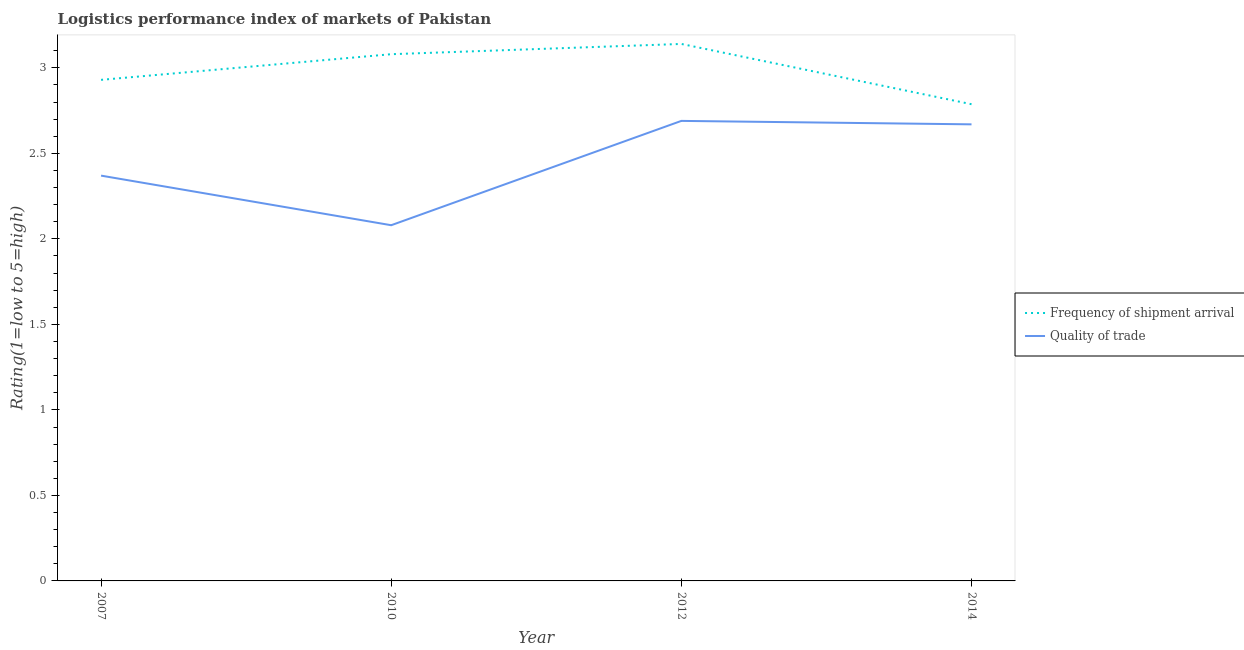Does the line corresponding to lpi of frequency of shipment arrival intersect with the line corresponding to lpi quality of trade?
Make the answer very short. No. What is the lpi of frequency of shipment arrival in 2012?
Give a very brief answer. 3.14. Across all years, what is the maximum lpi quality of trade?
Make the answer very short. 2.69. Across all years, what is the minimum lpi of frequency of shipment arrival?
Provide a succinct answer. 2.79. In which year was the lpi of frequency of shipment arrival maximum?
Ensure brevity in your answer.  2012. What is the total lpi quality of trade in the graph?
Keep it short and to the point. 9.81. What is the difference between the lpi quality of trade in 2007 and that in 2010?
Your answer should be very brief. 0.29. What is the difference between the lpi quality of trade in 2012 and the lpi of frequency of shipment arrival in 2007?
Give a very brief answer. -0.24. What is the average lpi quality of trade per year?
Give a very brief answer. 2.45. In the year 2007, what is the difference between the lpi quality of trade and lpi of frequency of shipment arrival?
Keep it short and to the point. -0.56. What is the ratio of the lpi of frequency of shipment arrival in 2010 to that in 2012?
Provide a short and direct response. 0.98. What is the difference between the highest and the second highest lpi quality of trade?
Your response must be concise. 0.02. What is the difference between the highest and the lowest lpi of frequency of shipment arrival?
Your answer should be very brief. 0.35. Is the sum of the lpi quality of trade in 2012 and 2014 greater than the maximum lpi of frequency of shipment arrival across all years?
Offer a very short reply. Yes. Does the lpi quality of trade monotonically increase over the years?
Keep it short and to the point. No. Is the lpi quality of trade strictly greater than the lpi of frequency of shipment arrival over the years?
Your answer should be compact. No. How many years are there in the graph?
Ensure brevity in your answer.  4. What is the difference between two consecutive major ticks on the Y-axis?
Ensure brevity in your answer.  0.5. Are the values on the major ticks of Y-axis written in scientific E-notation?
Offer a terse response. No. What is the title of the graph?
Provide a succinct answer. Logistics performance index of markets of Pakistan. Does "International Visitors" appear as one of the legend labels in the graph?
Keep it short and to the point. No. What is the label or title of the X-axis?
Your response must be concise. Year. What is the label or title of the Y-axis?
Keep it short and to the point. Rating(1=low to 5=high). What is the Rating(1=low to 5=high) of Frequency of shipment arrival in 2007?
Your response must be concise. 2.93. What is the Rating(1=low to 5=high) of Quality of trade in 2007?
Give a very brief answer. 2.37. What is the Rating(1=low to 5=high) in Frequency of shipment arrival in 2010?
Provide a succinct answer. 3.08. What is the Rating(1=low to 5=high) of Quality of trade in 2010?
Your answer should be very brief. 2.08. What is the Rating(1=low to 5=high) of Frequency of shipment arrival in 2012?
Ensure brevity in your answer.  3.14. What is the Rating(1=low to 5=high) of Quality of trade in 2012?
Give a very brief answer. 2.69. What is the Rating(1=low to 5=high) in Frequency of shipment arrival in 2014?
Provide a succinct answer. 2.79. What is the Rating(1=low to 5=high) of Quality of trade in 2014?
Keep it short and to the point. 2.67. Across all years, what is the maximum Rating(1=low to 5=high) of Frequency of shipment arrival?
Provide a short and direct response. 3.14. Across all years, what is the maximum Rating(1=low to 5=high) in Quality of trade?
Make the answer very short. 2.69. Across all years, what is the minimum Rating(1=low to 5=high) in Frequency of shipment arrival?
Offer a terse response. 2.79. Across all years, what is the minimum Rating(1=low to 5=high) of Quality of trade?
Make the answer very short. 2.08. What is the total Rating(1=low to 5=high) of Frequency of shipment arrival in the graph?
Offer a very short reply. 11.94. What is the total Rating(1=low to 5=high) in Quality of trade in the graph?
Your response must be concise. 9.81. What is the difference between the Rating(1=low to 5=high) in Frequency of shipment arrival in 2007 and that in 2010?
Give a very brief answer. -0.15. What is the difference between the Rating(1=low to 5=high) in Quality of trade in 2007 and that in 2010?
Your response must be concise. 0.29. What is the difference between the Rating(1=low to 5=high) of Frequency of shipment arrival in 2007 and that in 2012?
Give a very brief answer. -0.21. What is the difference between the Rating(1=low to 5=high) of Quality of trade in 2007 and that in 2012?
Your response must be concise. -0.32. What is the difference between the Rating(1=low to 5=high) of Frequency of shipment arrival in 2007 and that in 2014?
Ensure brevity in your answer.  0.14. What is the difference between the Rating(1=low to 5=high) of Quality of trade in 2007 and that in 2014?
Provide a succinct answer. -0.3. What is the difference between the Rating(1=low to 5=high) of Frequency of shipment arrival in 2010 and that in 2012?
Give a very brief answer. -0.06. What is the difference between the Rating(1=low to 5=high) in Quality of trade in 2010 and that in 2012?
Provide a succinct answer. -0.61. What is the difference between the Rating(1=low to 5=high) of Frequency of shipment arrival in 2010 and that in 2014?
Your answer should be compact. 0.29. What is the difference between the Rating(1=low to 5=high) in Quality of trade in 2010 and that in 2014?
Your answer should be very brief. -0.59. What is the difference between the Rating(1=low to 5=high) in Frequency of shipment arrival in 2012 and that in 2014?
Keep it short and to the point. 0.35. What is the difference between the Rating(1=low to 5=high) in Quality of trade in 2012 and that in 2014?
Give a very brief answer. 0.02. What is the difference between the Rating(1=low to 5=high) in Frequency of shipment arrival in 2007 and the Rating(1=low to 5=high) in Quality of trade in 2010?
Provide a short and direct response. 0.85. What is the difference between the Rating(1=low to 5=high) in Frequency of shipment arrival in 2007 and the Rating(1=low to 5=high) in Quality of trade in 2012?
Offer a very short reply. 0.24. What is the difference between the Rating(1=low to 5=high) of Frequency of shipment arrival in 2007 and the Rating(1=low to 5=high) of Quality of trade in 2014?
Offer a very short reply. 0.26. What is the difference between the Rating(1=low to 5=high) in Frequency of shipment arrival in 2010 and the Rating(1=low to 5=high) in Quality of trade in 2012?
Keep it short and to the point. 0.39. What is the difference between the Rating(1=low to 5=high) in Frequency of shipment arrival in 2010 and the Rating(1=low to 5=high) in Quality of trade in 2014?
Provide a succinct answer. 0.41. What is the difference between the Rating(1=low to 5=high) of Frequency of shipment arrival in 2012 and the Rating(1=low to 5=high) of Quality of trade in 2014?
Your response must be concise. 0.47. What is the average Rating(1=low to 5=high) of Frequency of shipment arrival per year?
Your response must be concise. 2.98. What is the average Rating(1=low to 5=high) of Quality of trade per year?
Offer a very short reply. 2.45. In the year 2007, what is the difference between the Rating(1=low to 5=high) of Frequency of shipment arrival and Rating(1=low to 5=high) of Quality of trade?
Make the answer very short. 0.56. In the year 2012, what is the difference between the Rating(1=low to 5=high) in Frequency of shipment arrival and Rating(1=low to 5=high) in Quality of trade?
Ensure brevity in your answer.  0.45. In the year 2014, what is the difference between the Rating(1=low to 5=high) of Frequency of shipment arrival and Rating(1=low to 5=high) of Quality of trade?
Give a very brief answer. 0.12. What is the ratio of the Rating(1=low to 5=high) of Frequency of shipment arrival in 2007 to that in 2010?
Your answer should be compact. 0.95. What is the ratio of the Rating(1=low to 5=high) of Quality of trade in 2007 to that in 2010?
Ensure brevity in your answer.  1.14. What is the ratio of the Rating(1=low to 5=high) in Frequency of shipment arrival in 2007 to that in 2012?
Provide a short and direct response. 0.93. What is the ratio of the Rating(1=low to 5=high) of Quality of trade in 2007 to that in 2012?
Offer a terse response. 0.88. What is the ratio of the Rating(1=low to 5=high) of Frequency of shipment arrival in 2007 to that in 2014?
Provide a succinct answer. 1.05. What is the ratio of the Rating(1=low to 5=high) in Quality of trade in 2007 to that in 2014?
Make the answer very short. 0.89. What is the ratio of the Rating(1=low to 5=high) of Frequency of shipment arrival in 2010 to that in 2012?
Offer a very short reply. 0.98. What is the ratio of the Rating(1=low to 5=high) of Quality of trade in 2010 to that in 2012?
Ensure brevity in your answer.  0.77. What is the ratio of the Rating(1=low to 5=high) of Frequency of shipment arrival in 2010 to that in 2014?
Offer a very short reply. 1.1. What is the ratio of the Rating(1=low to 5=high) of Quality of trade in 2010 to that in 2014?
Keep it short and to the point. 0.78. What is the ratio of the Rating(1=low to 5=high) of Frequency of shipment arrival in 2012 to that in 2014?
Provide a succinct answer. 1.13. What is the ratio of the Rating(1=low to 5=high) of Quality of trade in 2012 to that in 2014?
Provide a succinct answer. 1.01. What is the difference between the highest and the second highest Rating(1=low to 5=high) in Quality of trade?
Keep it short and to the point. 0.02. What is the difference between the highest and the lowest Rating(1=low to 5=high) in Frequency of shipment arrival?
Provide a short and direct response. 0.35. What is the difference between the highest and the lowest Rating(1=low to 5=high) in Quality of trade?
Keep it short and to the point. 0.61. 